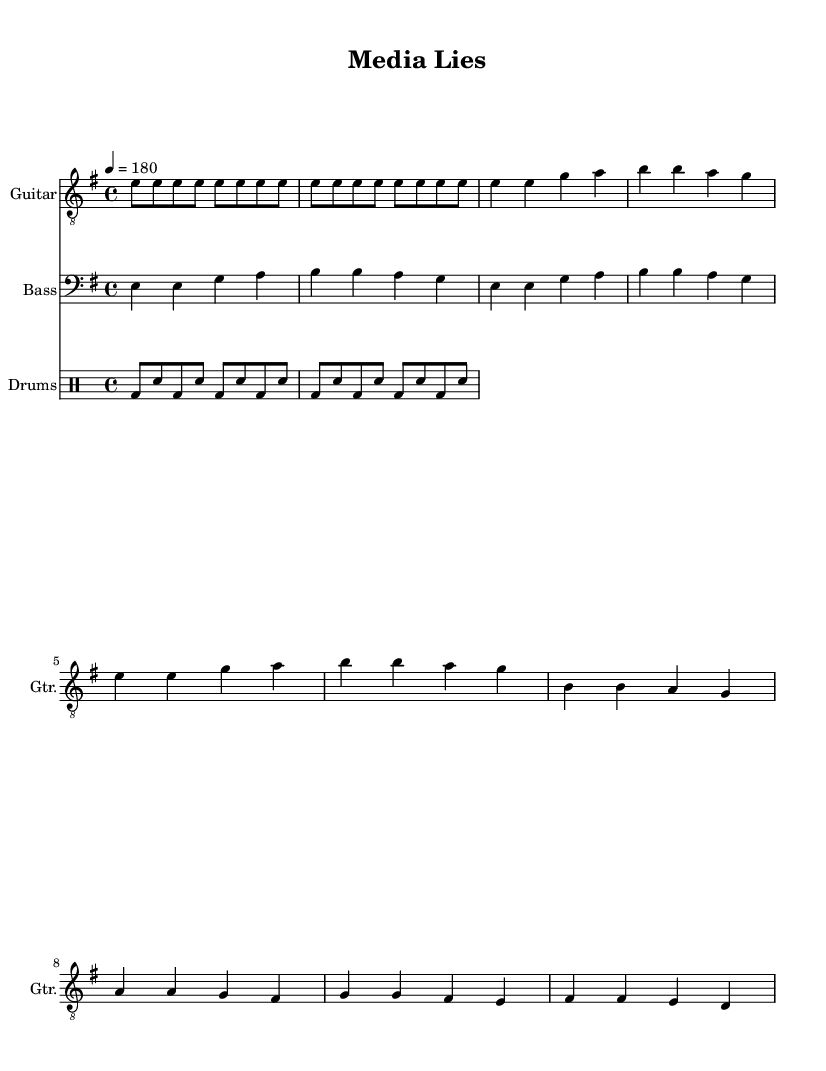What is the key signature of this music? The key signature is E minor, which has one sharp (F#).
Answer: E minor What is the time signature of this music? The time signature is 4/4, indicating four beats in each measure.
Answer: 4/4 What is the tempo marking of this piece? The tempo marking is 180 beats per minute, indicated by the note "4 = 180".
Answer: 180 How many measures are in the verse section? The verse consists of four measures, as counted in the written notes.
Answer: 4 Which instrument plays the main riff? The Guitar staff is where the main riff is located, indicated in the score for Guitar.
Answer: Guitar Does the chorus have more notes than the verse? The chorus consists of four measures as in the verse, but the note variety might differ; both sections have equal measure counts.
Answer: No What type of music is represented in this sheet? This sheet represents punk music, characterized by its energetic play and anti-establishment themes.
Answer: Punk 